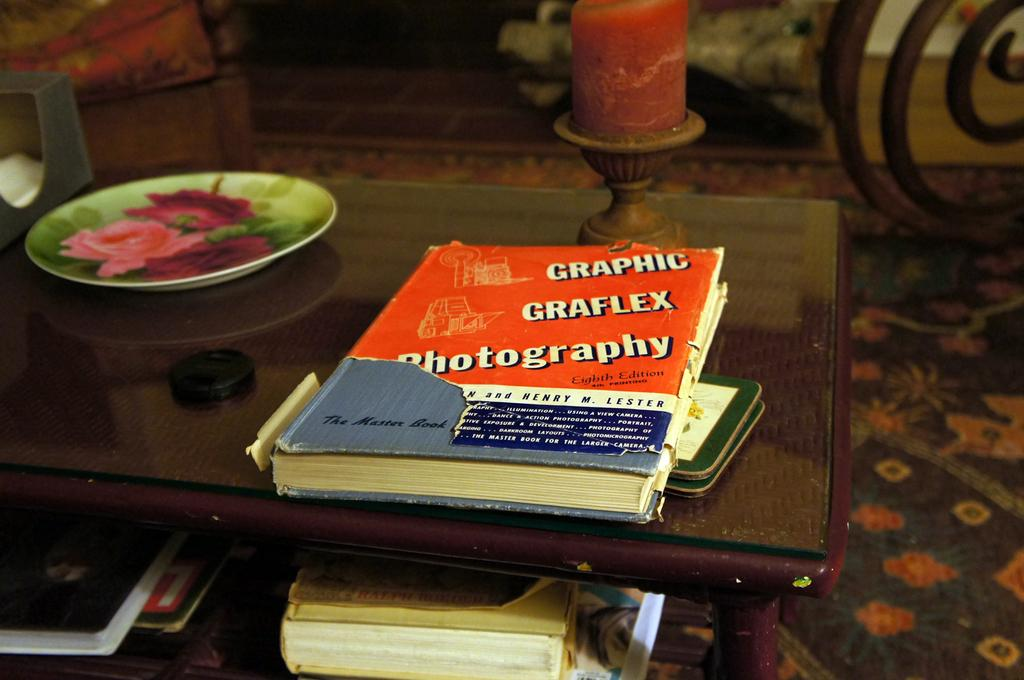<image>
Provide a brief description of the given image. The book is about using Graphic Graflex Photography 